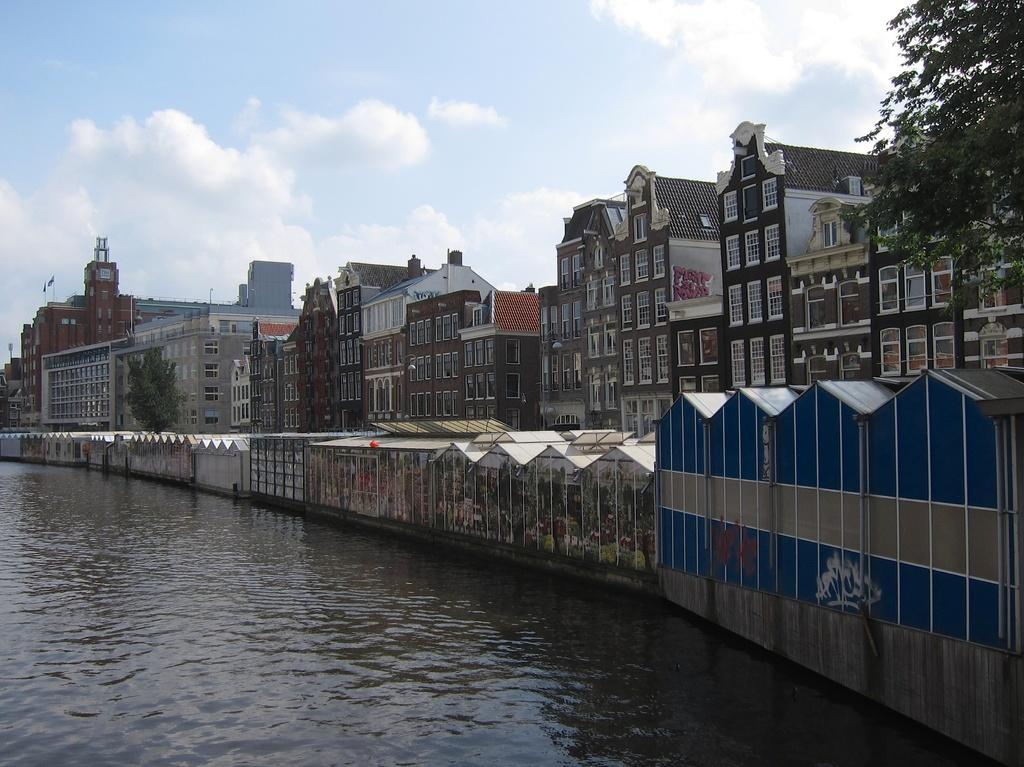What is the primary element visible in the image? There is water in the image. What can be seen in the background of the image? There is a wall and buildings on the right side of the image. What type of vegetation is present in the image? There are trees on the right side of the image. What is visible in the sky in the image? There are clouds in the sky. What type of disgust can be seen on the wall in the image? There is no indication of disgust in the image; the wall is simply a part of the background. 